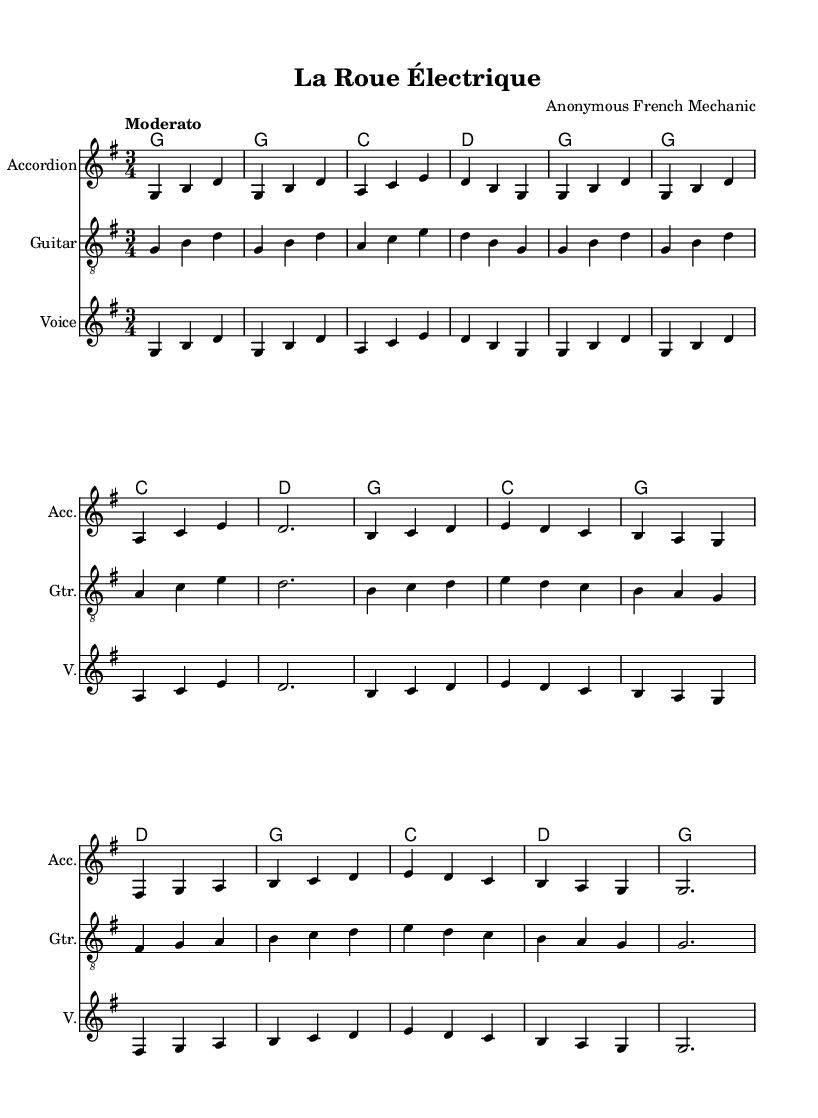What is the key signature of this music? The key signature is G major, which has one sharp (F#). This can be identified by looking at the key signature shown at the beginning of the music.
Answer: G major What is the time signature? The time signature is 3/4, indicating three beats per measure and a quarter note gets one beat. This is seen at the beginning of the sheet music next to the key signature.
Answer: 3/4 What is the tempo of the piece? The tempo is marked as "Moderato." This indication appears at the start of the piece and tells the performer to play at a moderately fast speed.
Answer: Moderato How many measures are there in the melody? The melody consists of 16 measures. This can be determined by counting the distinct groups of notes and the corresponding bar lines that separate them in the melody section.
Answer: 16 What instruments are featured in this arrangement? The arrangement includes Accordion, Guitar, and Voice. This information is indicated at the beginning of each staff in the score.
Answer: Accordion, Guitar, Voice What themes are expressed in the lyrics? The lyrics express themes of technological evolution in transportation, specifically focusing on the transition from traditional wheeled vehicles to electric ones. This can be inferred from the content of the verses and chorus.
Answer: Evolution of transportation 